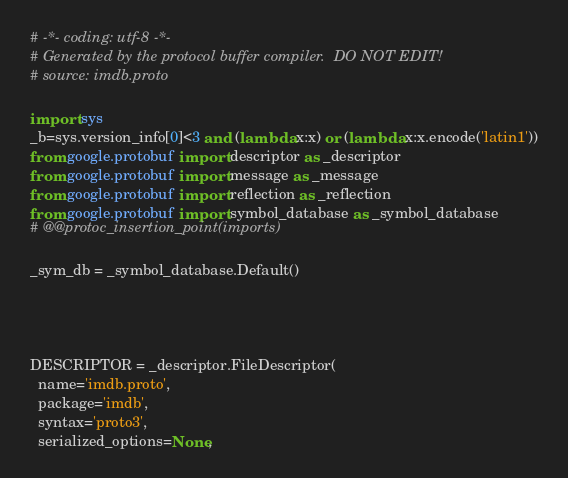Convert code to text. <code><loc_0><loc_0><loc_500><loc_500><_Python_># -*- coding: utf-8 -*-
# Generated by the protocol buffer compiler.  DO NOT EDIT!
# source: imdb.proto

import sys
_b=sys.version_info[0]<3 and (lambda x:x) or (lambda x:x.encode('latin1'))
from google.protobuf import descriptor as _descriptor
from google.protobuf import message as _message
from google.protobuf import reflection as _reflection
from google.protobuf import symbol_database as _symbol_database
# @@protoc_insertion_point(imports)

_sym_db = _symbol_database.Default()




DESCRIPTOR = _descriptor.FileDescriptor(
  name='imdb.proto',
  package='imdb',
  syntax='proto3',
  serialized_options=None,</code> 